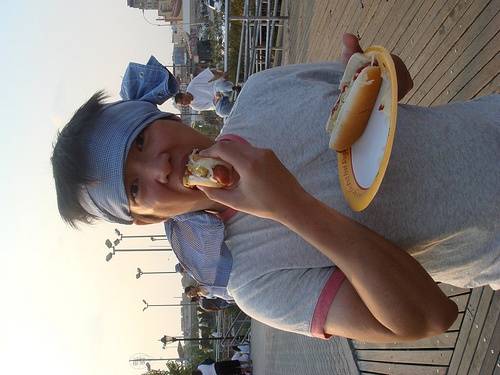Describe the objects in this image and their specific colors. I can see people in lightblue, gray, maroon, and black tones, hot dog in lightgray, maroon, and gray tones, people in lightgray, darkgray, gray, black, and maroon tones, hot dog in lightgray, maroon, and gray tones, and people in lightgray, black, and gray tones in this image. 